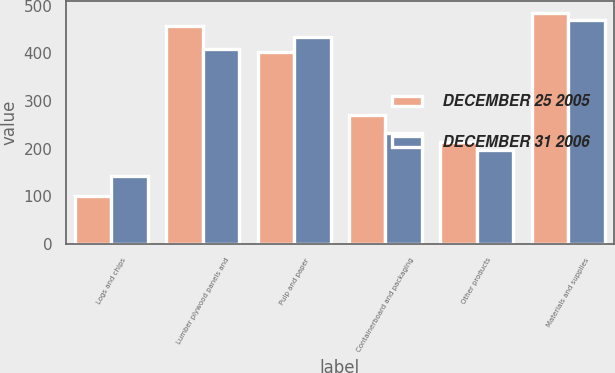<chart> <loc_0><loc_0><loc_500><loc_500><stacked_bar_chart><ecel><fcel>Logs and chips<fcel>Lumber plywood panels and<fcel>Pulp and paper<fcel>Containerboard and packaging<fcel>Other products<fcel>Materials and supplies<nl><fcel>DECEMBER 25 2005<fcel>101<fcel>457<fcel>402<fcel>270<fcel>214<fcel>485<nl><fcel>DECEMBER 31 2006<fcel>142<fcel>409<fcel>435<fcel>232<fcel>196<fcel>471<nl></chart> 